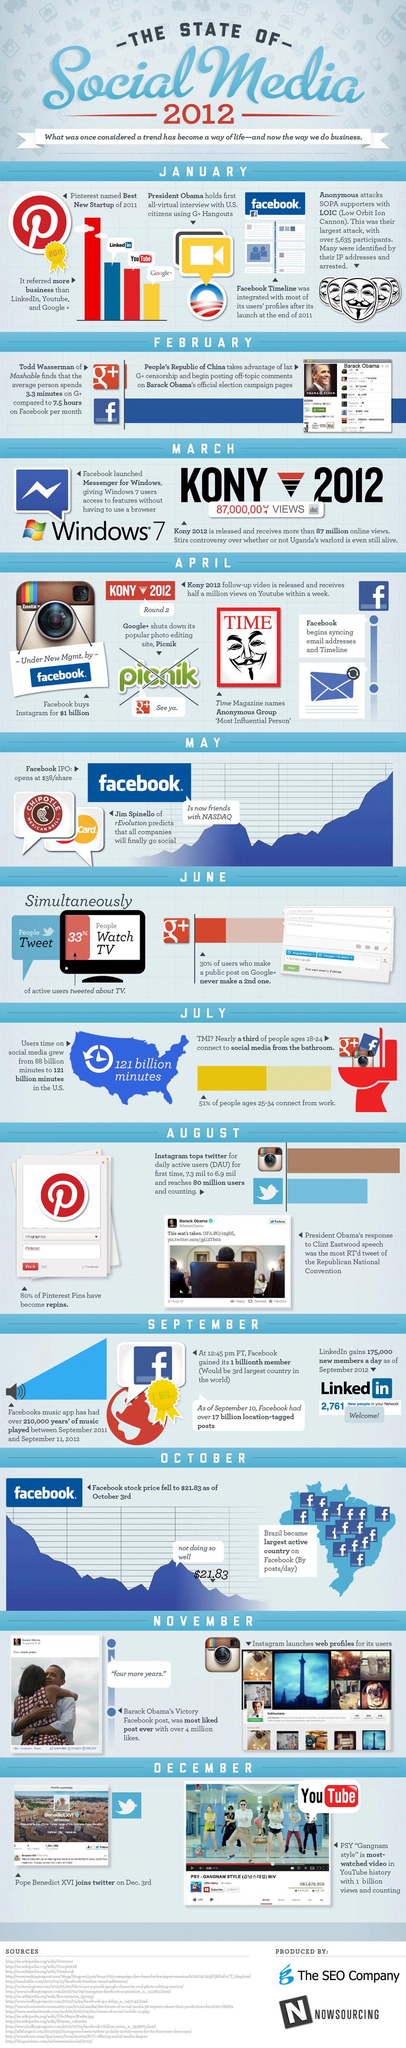Specify some key components in this picture. LinkedIn, the second best new startup of 2011, is a popular professional networking site. YouTube is the third-best new startup of 2011. According to a recent survey, 67% of people are not watching TV. 